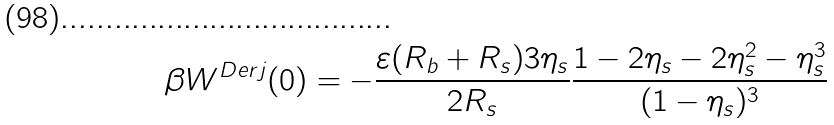<formula> <loc_0><loc_0><loc_500><loc_500>\beta W ^ { D e r j } ( 0 ) = - \frac { \varepsilon ( R _ { b } + R _ { s } ) 3 \eta _ { s } } { 2 R _ { s } } \frac { 1 - 2 \eta _ { s } - 2 \eta _ { s } ^ { 2 } - \eta _ { s } ^ { 3 } } { ( 1 - \eta _ { s } ) ^ { 3 } }</formula> 